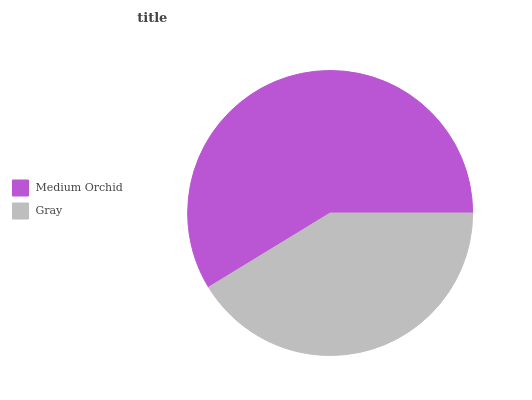Is Gray the minimum?
Answer yes or no. Yes. Is Medium Orchid the maximum?
Answer yes or no. Yes. Is Gray the maximum?
Answer yes or no. No. Is Medium Orchid greater than Gray?
Answer yes or no. Yes. Is Gray less than Medium Orchid?
Answer yes or no. Yes. Is Gray greater than Medium Orchid?
Answer yes or no. No. Is Medium Orchid less than Gray?
Answer yes or no. No. Is Medium Orchid the high median?
Answer yes or no. Yes. Is Gray the low median?
Answer yes or no. Yes. Is Gray the high median?
Answer yes or no. No. Is Medium Orchid the low median?
Answer yes or no. No. 